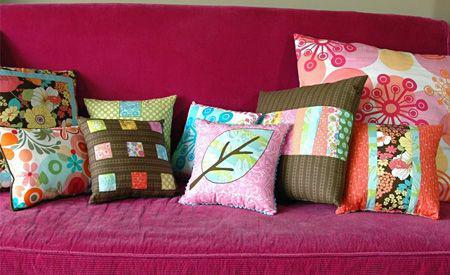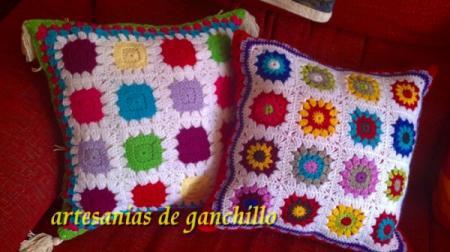The first image is the image on the left, the second image is the image on the right. For the images displayed, is the sentence "At least one of the sofas is a solid pink color." factually correct? Answer yes or no. Yes. 